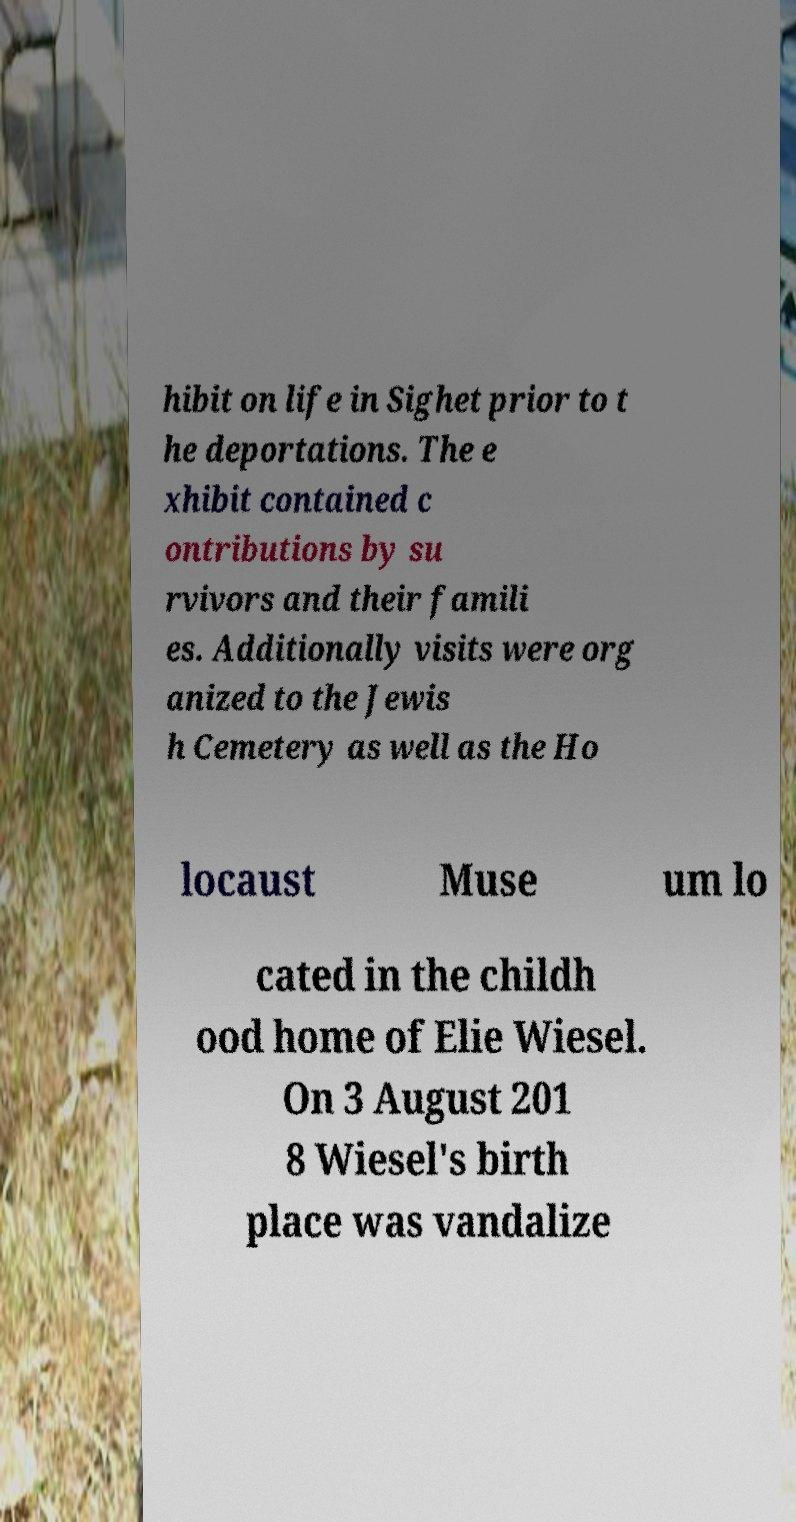Please read and relay the text visible in this image. What does it say? hibit on life in Sighet prior to t he deportations. The e xhibit contained c ontributions by su rvivors and their famili es. Additionally visits were org anized to the Jewis h Cemetery as well as the Ho locaust Muse um lo cated in the childh ood home of Elie Wiesel. On 3 August 201 8 Wiesel's birth place was vandalize 